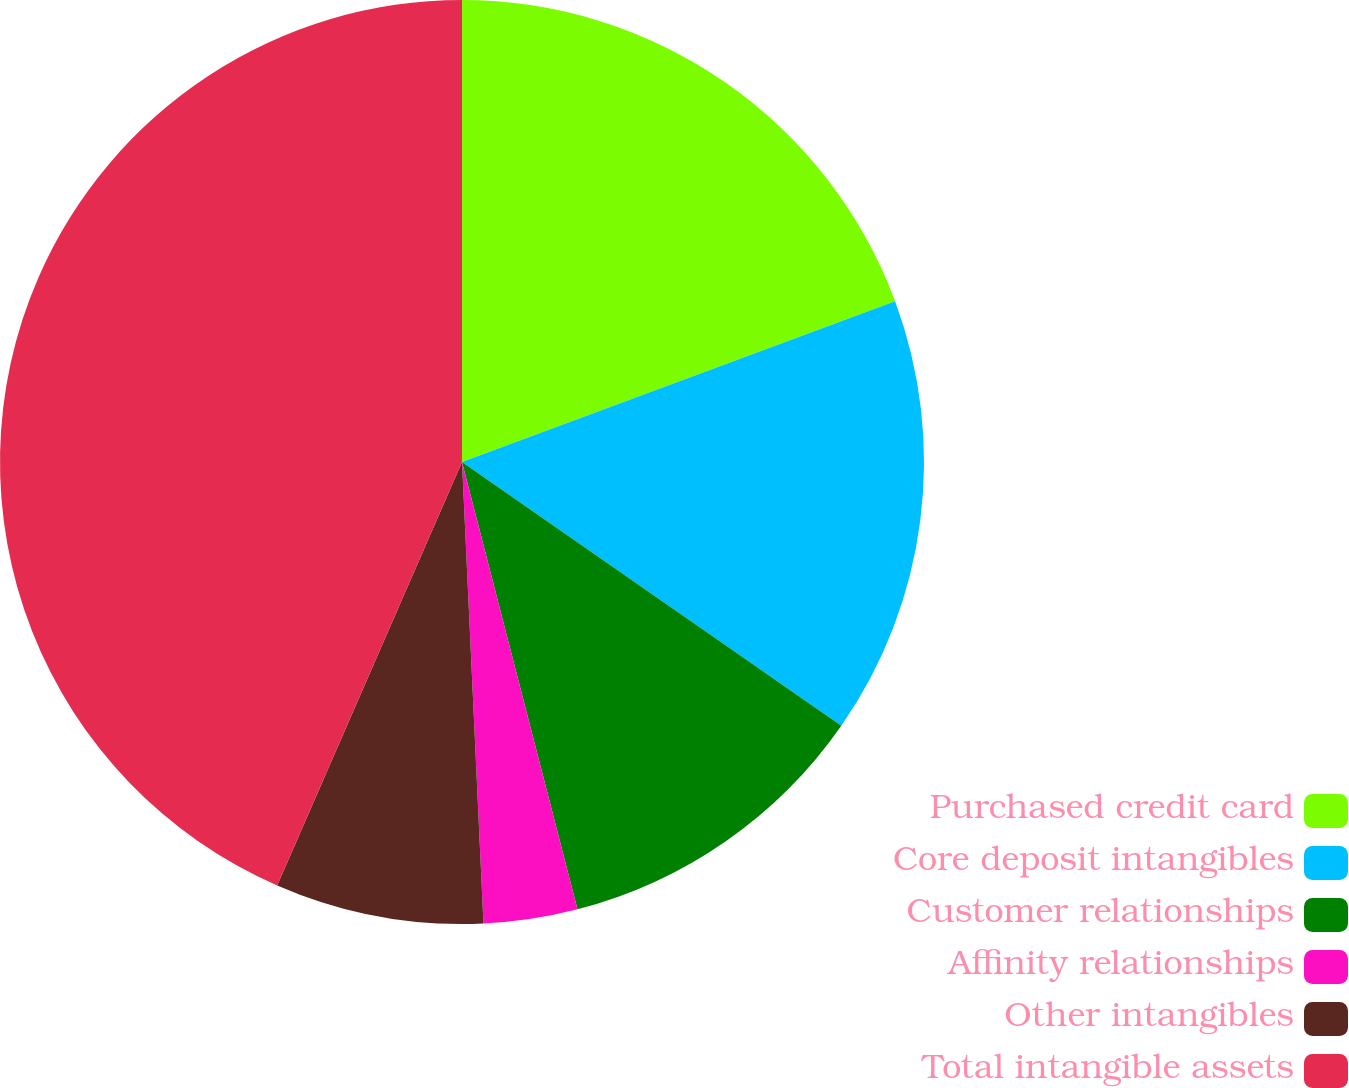<chart> <loc_0><loc_0><loc_500><loc_500><pie_chart><fcel>Purchased credit card<fcel>Core deposit intangibles<fcel>Customer relationships<fcel>Affinity relationships<fcel>Other intangibles<fcel>Total intangible assets<nl><fcel>19.34%<fcel>15.33%<fcel>11.31%<fcel>3.28%<fcel>7.29%<fcel>43.45%<nl></chart> 